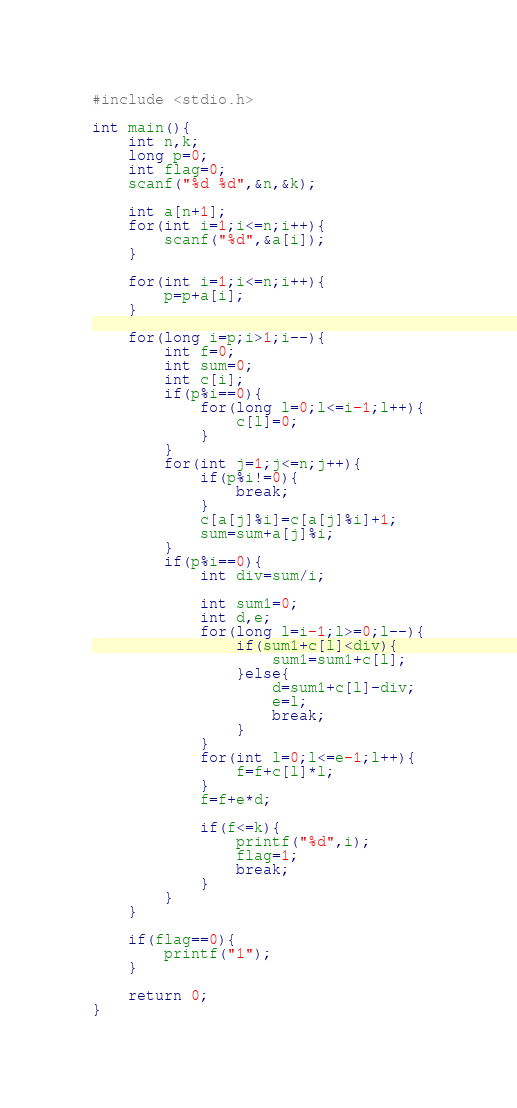Convert code to text. <code><loc_0><loc_0><loc_500><loc_500><_C_>#include <stdio.h>

int main(){
    int n,k;
    long p=0;
    int flag=0;
    scanf("%d %d",&n,&k);
    
    int a[n+1];
    for(int i=1;i<=n;i++){
        scanf("%d",&a[i]);
    }
    
    for(int i=1;i<=n;i++){
        p=p+a[i];
    }
    
    for(long i=p;i>1;i--){
        int f=0;
        int sum=0;
        int c[i];
        if(p%i==0){
            for(long l=0;l<=i-1;l++){
                c[l]=0;
            }
        }
        for(int j=1;j<=n;j++){
            if(p%i!=0){
                break;
            }
            c[a[j]%i]=c[a[j]%i]+1;
            sum=sum+a[j]%i;
        }
        if(p%i==0){
            int div=sum/i;
            
            int sum1=0;
            int d,e;
            for(long l=i-1;l>=0;l--){
                if(sum1+c[l]<div){
                    sum1=sum1+c[l];
                }else{
                    d=sum1+c[l]-div;
                    e=l;
                    break;
                }
            }
            for(int l=0;l<=e-1;l++){
                f=f+c[l]*l;
            }
            f=f+e*d;
            
            if(f<=k){
                printf("%d",i);
                flag=1;
                break;
            }
        }
    }
    
    if(flag==0){
        printf("1");
    }
    
    return 0;
}
</code> 